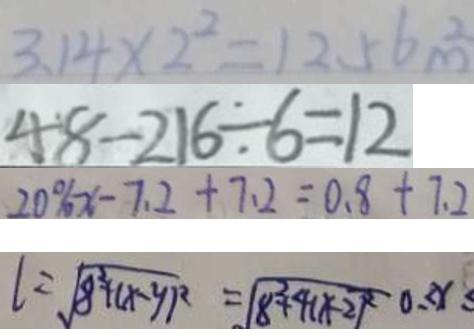Convert formula to latex. <formula><loc_0><loc_0><loc_500><loc_500>3 . 1 4 \times 2 ^ { 2 } = 1 2 . 5 6 m ^ { 2 } 
 4 8 - 2 1 6 \div 6 = 1 2 
 2 0 \% x - 7 . 2 + 7 . 2 = 0 . 8 + 7 . 2 
 l = \sqrt { 8 ^ { 2 } + ( x - y ) ^ { 2 } } = \sqrt { 8 ^ { 2 } + 4 ( x - 2 ) ^ { 2 } } 0 \leq x \leq</formula> 